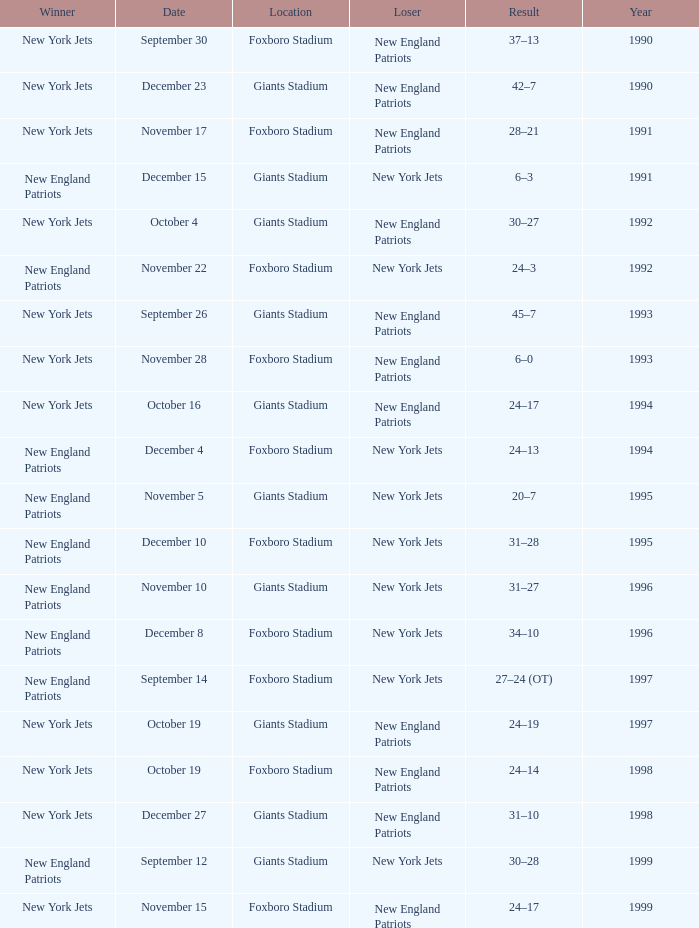What is the location when the new york jets lost earlier than 1997 and a Result of 31–28? Foxboro Stadium. Parse the table in full. {'header': ['Winner', 'Date', 'Location', 'Loser', 'Result', 'Year'], 'rows': [['New York Jets', 'September 30', 'Foxboro Stadium', 'New England Patriots', '37–13', '1990'], ['New York Jets', 'December 23', 'Giants Stadium', 'New England Patriots', '42–7', '1990'], ['New York Jets', 'November 17', 'Foxboro Stadium', 'New England Patriots', '28–21', '1991'], ['New England Patriots', 'December 15', 'Giants Stadium', 'New York Jets', '6–3', '1991'], ['New York Jets', 'October 4', 'Giants Stadium', 'New England Patriots', '30–27', '1992'], ['New England Patriots', 'November 22', 'Foxboro Stadium', 'New York Jets', '24–3', '1992'], ['New York Jets', 'September 26', 'Giants Stadium', 'New England Patriots', '45–7', '1993'], ['New York Jets', 'November 28', 'Foxboro Stadium', 'New England Patriots', '6–0', '1993'], ['New York Jets', 'October 16', 'Giants Stadium', 'New England Patriots', '24–17', '1994'], ['New England Patriots', 'December 4', 'Foxboro Stadium', 'New York Jets', '24–13', '1994'], ['New England Patriots', 'November 5', 'Giants Stadium', 'New York Jets', '20–7', '1995'], ['New England Patriots', 'December 10', 'Foxboro Stadium', 'New York Jets', '31–28', '1995'], ['New England Patriots', 'November 10', 'Giants Stadium', 'New York Jets', '31–27', '1996'], ['New England Patriots', 'December 8', 'Foxboro Stadium', 'New York Jets', '34–10', '1996'], ['New England Patriots', 'September 14', 'Foxboro Stadium', 'New York Jets', '27–24 (OT)', '1997'], ['New York Jets', 'October 19', 'Giants Stadium', 'New England Patriots', '24–19', '1997'], ['New York Jets', 'October 19', 'Foxboro Stadium', 'New England Patriots', '24–14', '1998'], ['New York Jets', 'December 27', 'Giants Stadium', 'New England Patriots', '31–10', '1998'], ['New England Patriots', 'September 12', 'Giants Stadium', 'New York Jets', '30–28', '1999'], ['New York Jets', 'November 15', 'Foxboro Stadium', 'New England Patriots', '24–17', '1999']]} 